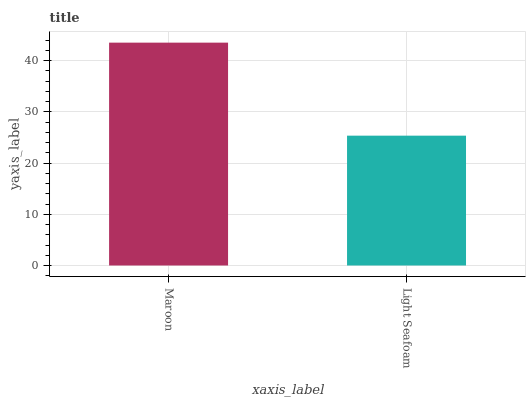Is Light Seafoam the minimum?
Answer yes or no. Yes. Is Maroon the maximum?
Answer yes or no. Yes. Is Light Seafoam the maximum?
Answer yes or no. No. Is Maroon greater than Light Seafoam?
Answer yes or no. Yes. Is Light Seafoam less than Maroon?
Answer yes or no. Yes. Is Light Seafoam greater than Maroon?
Answer yes or no. No. Is Maroon less than Light Seafoam?
Answer yes or no. No. Is Maroon the high median?
Answer yes or no. Yes. Is Light Seafoam the low median?
Answer yes or no. Yes. Is Light Seafoam the high median?
Answer yes or no. No. Is Maroon the low median?
Answer yes or no. No. 